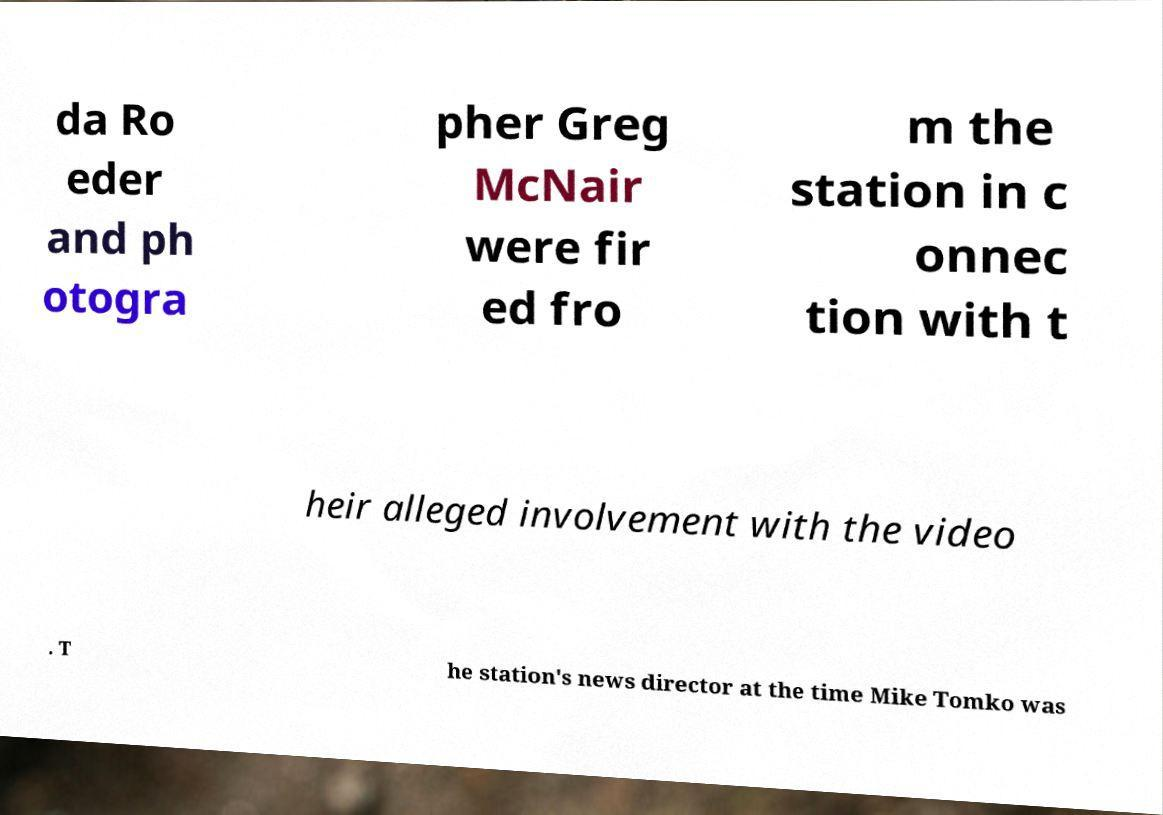Could you extract and type out the text from this image? da Ro eder and ph otogra pher Greg McNair were fir ed fro m the station in c onnec tion with t heir alleged involvement with the video . T he station's news director at the time Mike Tomko was 